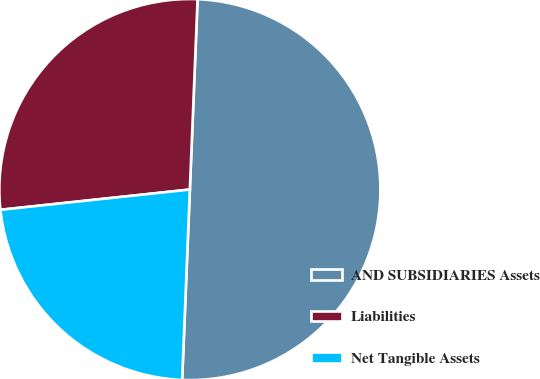Convert chart. <chart><loc_0><loc_0><loc_500><loc_500><pie_chart><fcel>AND SUBSIDIARIES Assets<fcel>Liabilities<fcel>Net Tangible Assets<nl><fcel>50.0%<fcel>27.34%<fcel>22.66%<nl></chart> 